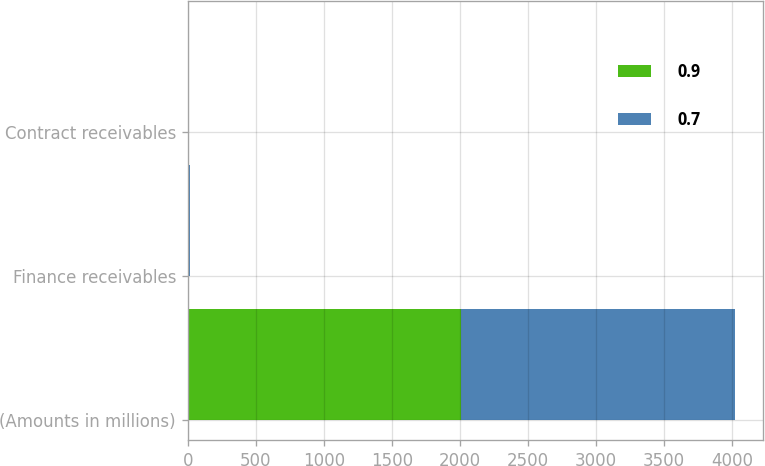<chart> <loc_0><loc_0><loc_500><loc_500><stacked_bar_chart><ecel><fcel>(Amounts in millions)<fcel>Finance receivables<fcel>Contract receivables<nl><fcel>0.9<fcel>2012<fcel>7.2<fcel>0.9<nl><fcel>0.7<fcel>2011<fcel>6.8<fcel>0.7<nl></chart> 